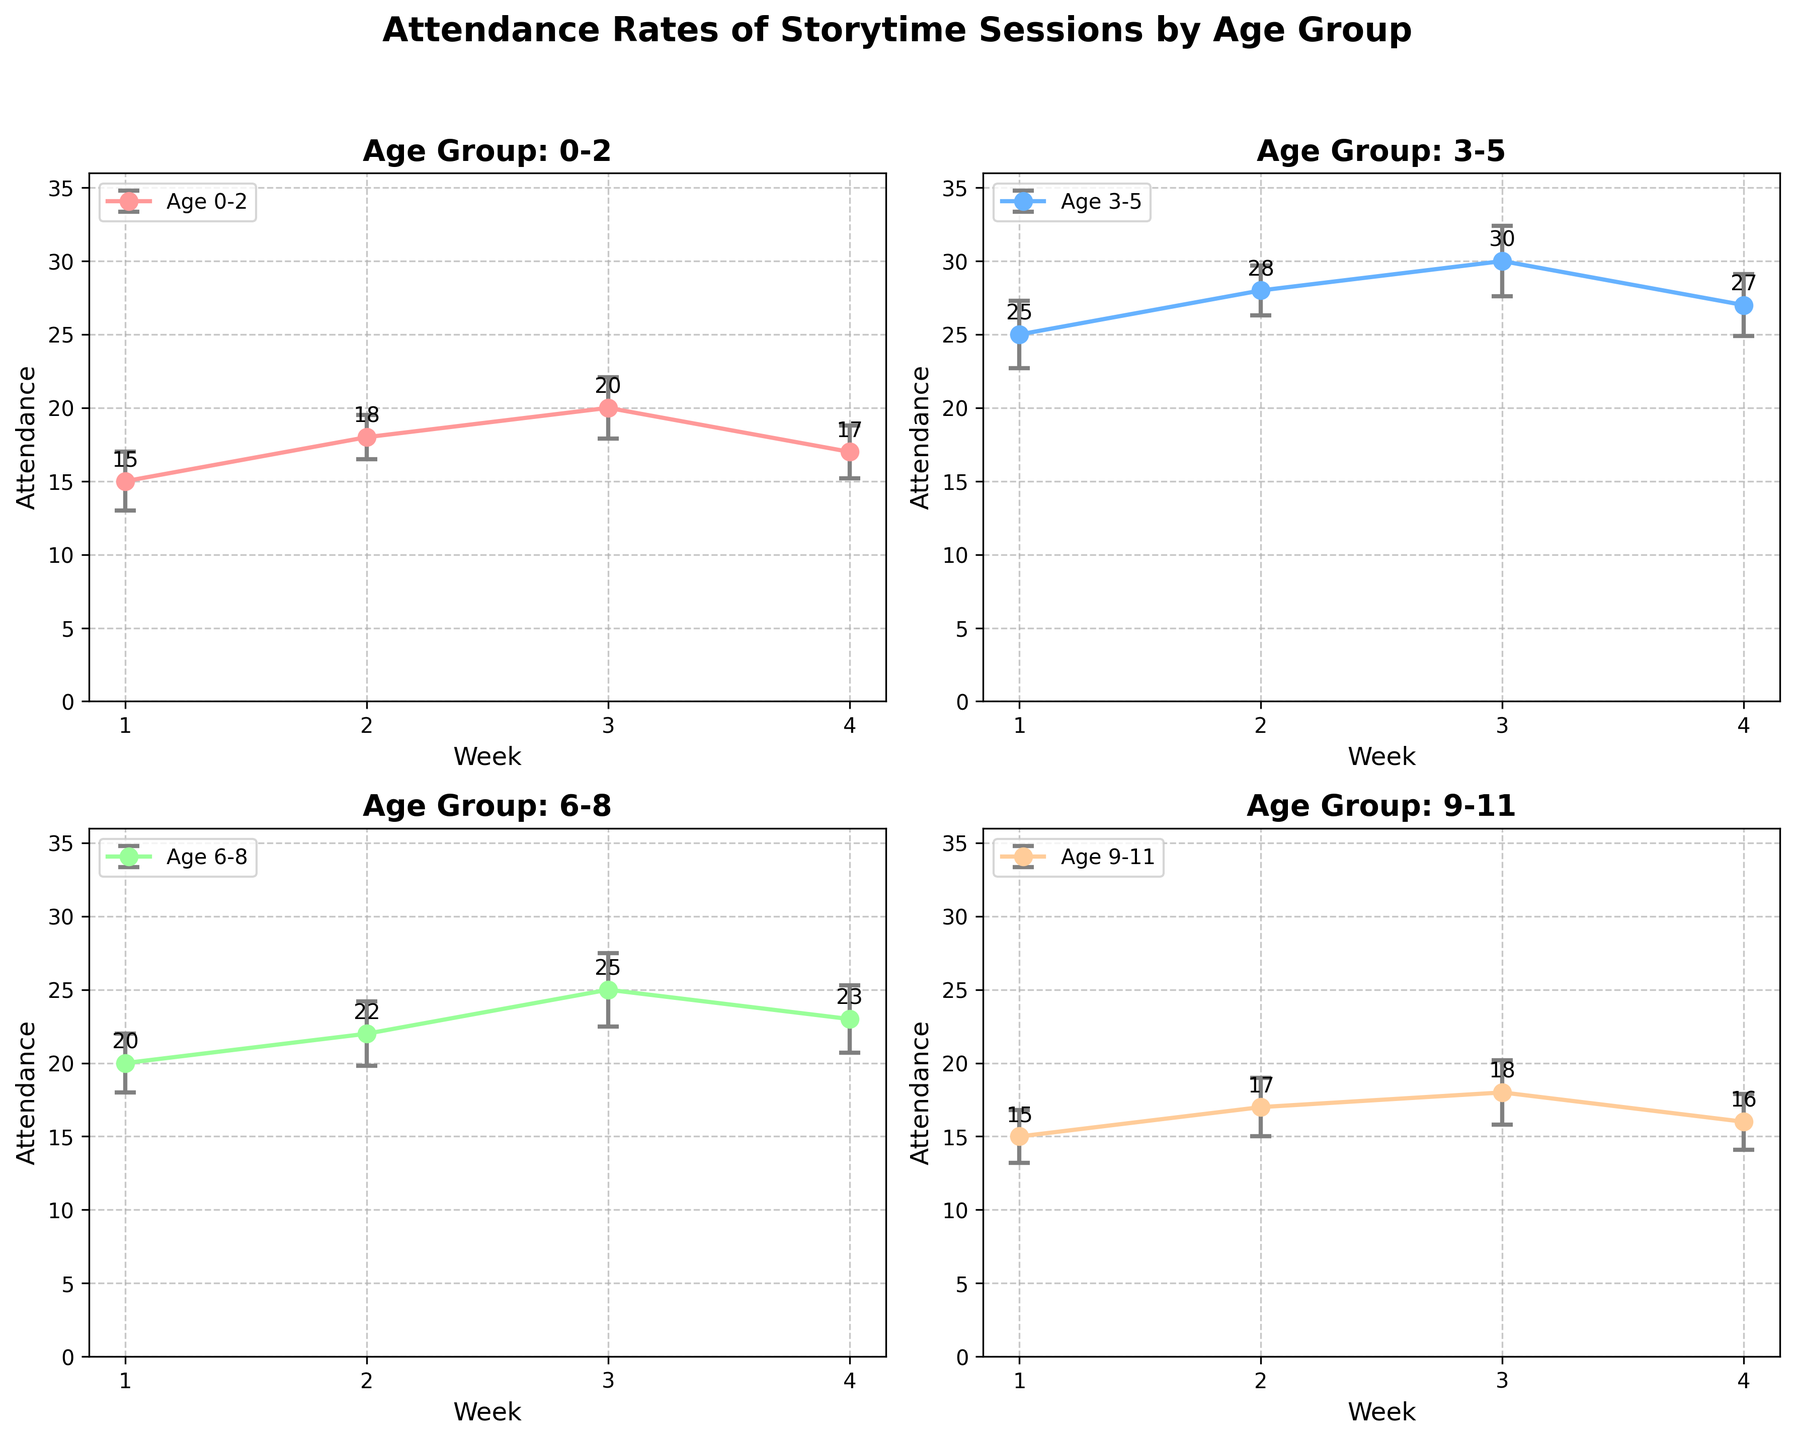What's the title of the figure? The title of the figure is placed at the top and usually summarizes the main topic represented by the chart, indicating it shows "Attendance Rates of Storytime Sessions by Age Group".
Answer: Attendance Rates of Storytime Sessions by Age Group How many weeks are shown in the figure for each age group? Each subplot contains data points representing weekly attendance, marked on the x-axis for each age group; there are four weeks shown.
Answer: 4 Which age group had the highest attendance in Week 3? Observing each subplot, the highest attendance value for Week 3 is 30, found in the plot representing the 3-5 age group.
Answer: 3-5 What's the average attendance for the 9-11 age group over the four weeks? Sum the weekly attendance values for the 9-11 age group (15 + 17 + 18 + 16) and divide by 4. So, the total is 66 and the average is 66 / 4.
Answer: 16.5 Which age group shows the most variation in attendance over the weeks? The variation is indicated by the spread of the attendance points and can also be inferred from the errors bars. The 3-5 age group has the largest range from 25 to 30, and larger error bars overall.
Answer: 3-5 Compare the attendance trends of the 0-2 and 9-11 age groups. What can you infer? The attendance for 0-2 rises and peaks at Week 3 before dropping slightly, whereas the 9-11 group shows a small increase over Weeks 1-3 and then a drop in Week 4.
Answer: 0-2 group peak at Week 3 and drop in Week 4, 9-11 group rise and fall evenly What is the total attendance for the 6-8 age group over the four weeks? Add up the attendance numbers for the 6-8 age group over the four weeks: (20 + 22 + 25 + 23). The sum is 90.
Answer: 90 Which week shows the highest overall attendance across all age groups? Observe each subplot for the highest attendance numbers in each week, compare them. Week 3 shows the highest attendance with numbers like 20 (0-2), 30 (3-5), 25 (6-8), and 18 (9-11), summing up to the highest overall attendance.
Answer: Week 3 How do the error bars for the 3-5 age group in Week 2 compare to those of Week 4? Error bars represent the standard error. In Week 2, the error bar is smaller (about 1.7) compared to Week 4 (about 2.1), indicating less variability in Week 2.
Answer: Smaller in Week 2 Is there a week where all age groups show the weakest attendance? Referring to each subplot's lowest points across all weeks, Week 1 has comparably lower attendance figures (15 for 0-2, 25 for 3-5, 20 for 6-8, and 15 for 9-11).
Answer: Week 1 